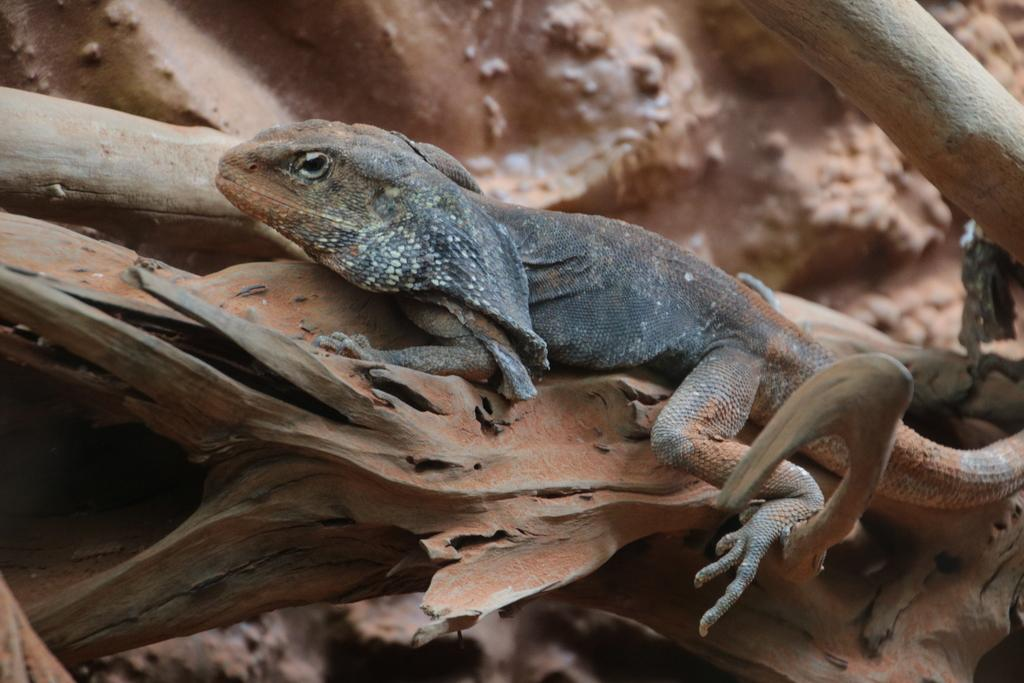What type of animal is in the image? There is a reptile in the image. Where is the reptile located? The reptile is on a tree. Can you describe the position of the tree in the image? The tree is in the center of the image. What type of form does the reptile take on during the day? A: The image does not provide information about the reptile's form during the day, as it only shows the reptile on a tree. What song is the reptile singing while on the tree? The image does not show or suggest that the reptile is singing a song. 